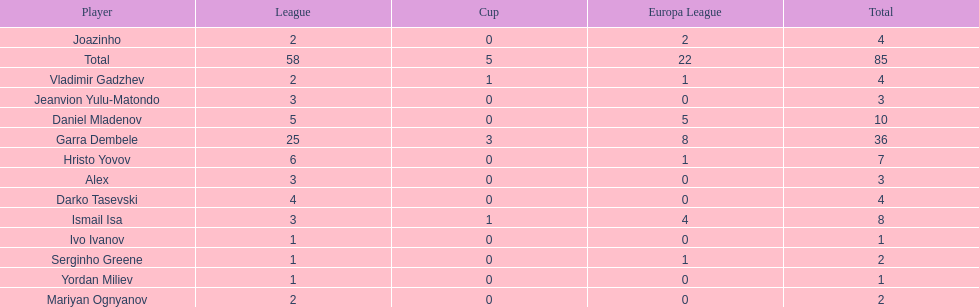Write the full table. {'header': ['Player', 'League', 'Cup', 'Europa League', 'Total'], 'rows': [['Joazinho', '2', '0', '2', '4'], ['Total', '58', '5', '22', '85'], ['Vladimir Gadzhev', '2', '1', '1', '4'], ['Jeanvion Yulu-Matondo', '3', '0', '0', '3'], ['Daniel Mladenov', '5', '0', '5', '10'], ['Garra Dembele', '25', '3', '8', '36'], ['Hristo Yovov', '6', '0', '1', '7'], ['Alex', '3', '0', '0', '3'], ['Darko Tasevski', '4', '0', '0', '4'], ['Ismail Isa', '3', '1', '4', '8'], ['Ivo Ivanov', '1', '0', '0', '1'], ['Serginho Greene', '1', '0', '1', '2'], ['Yordan Miliev', '1', '0', '0', '1'], ['Mariyan Ognyanov', '2', '0', '0', '2']]} What is the difference between vladimir gadzhev and yordan miliev's scores? 3. 